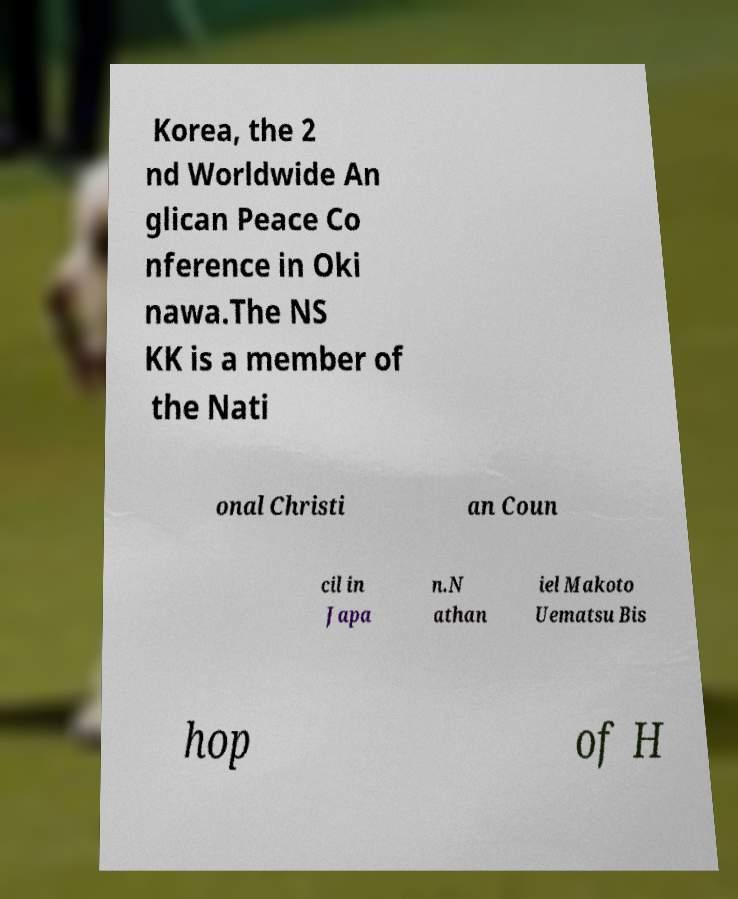Please read and relay the text visible in this image. What does it say? Korea, the 2 nd Worldwide An glican Peace Co nference in Oki nawa.The NS KK is a member of the Nati onal Christi an Coun cil in Japa n.N athan iel Makoto Uematsu Bis hop of H 